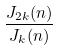Convert formula to latex. <formula><loc_0><loc_0><loc_500><loc_500>\frac { J _ { 2 k } ( n ) } { J _ { k } ( n ) }</formula> 